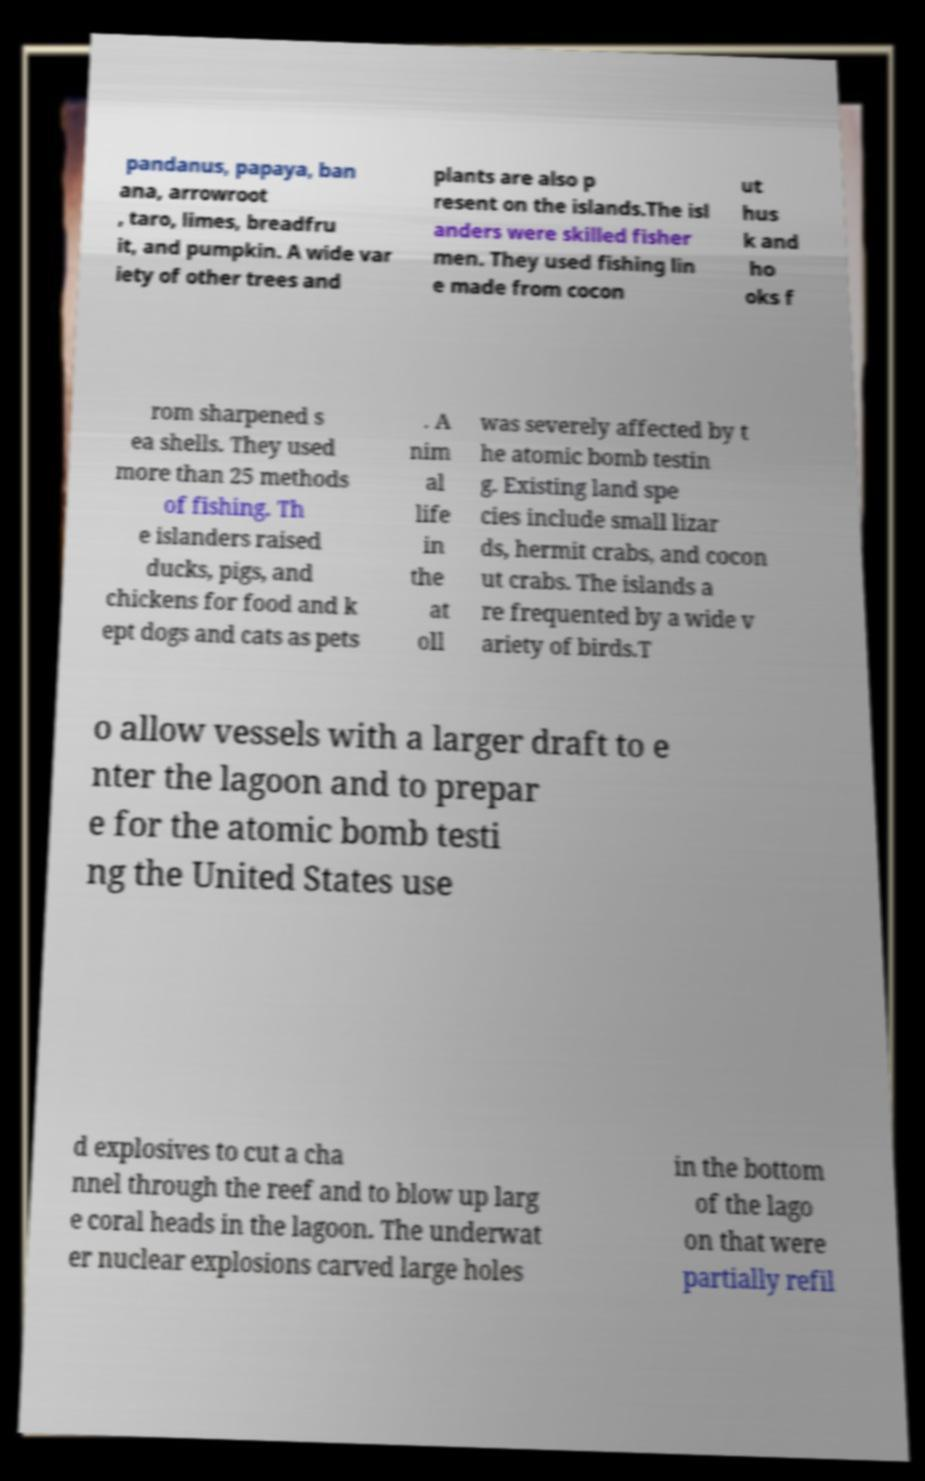Could you extract and type out the text from this image? pandanus, papaya, ban ana, arrowroot , taro, limes, breadfru it, and pumpkin. A wide var iety of other trees and plants are also p resent on the islands.The isl anders were skilled fisher men. They used fishing lin e made from cocon ut hus k and ho oks f rom sharpened s ea shells. They used more than 25 methods of fishing. Th e islanders raised ducks, pigs, and chickens for food and k ept dogs and cats as pets . A nim al life in the at oll was severely affected by t he atomic bomb testin g. Existing land spe cies include small lizar ds, hermit crabs, and cocon ut crabs. The islands a re frequented by a wide v ariety of birds.T o allow vessels with a larger draft to e nter the lagoon and to prepar e for the atomic bomb testi ng the United States use d explosives to cut a cha nnel through the reef and to blow up larg e coral heads in the lagoon. The underwat er nuclear explosions carved large holes in the bottom of the lago on that were partially refil 